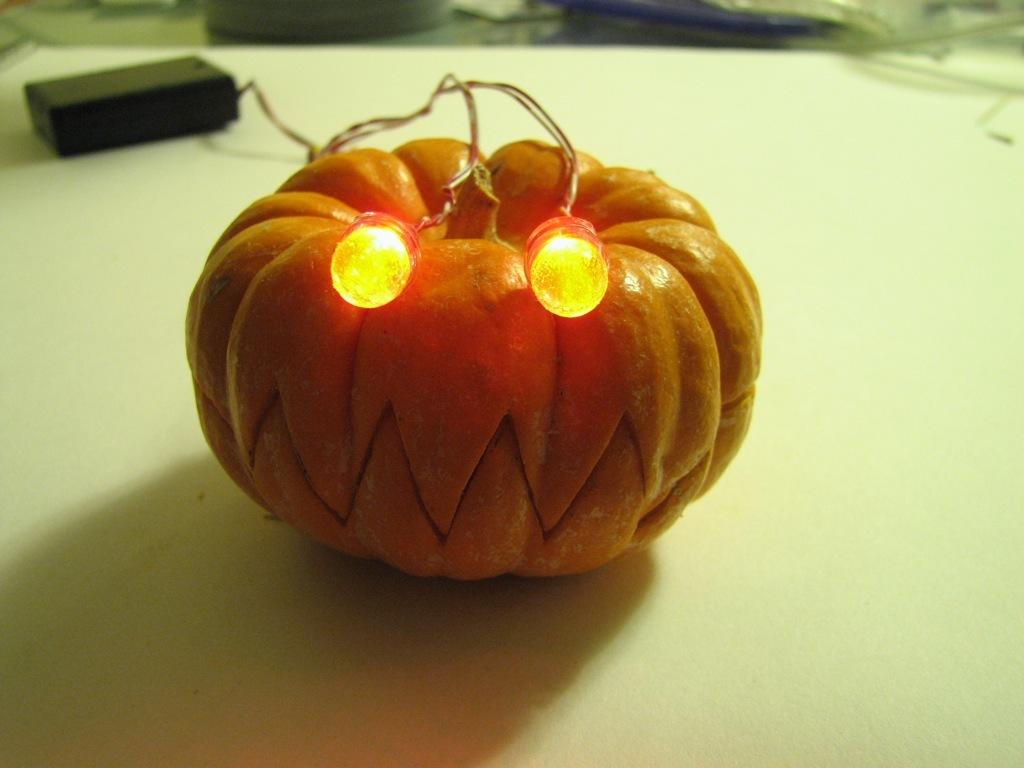What is the color of the pumpkin in the image? The pumpkin in the image is orange. What can be seen illuminated in the image? There are lights visible in the image. What is present alongside the lights? There are wires in the image. What is visible in the background of the image? There is a black color thing in the background of the image. How is the background of the image? The background of the image is slightly blurry. What type of drink is being served by the person's brother in the image? There is no person or brother present in the image, and therefore no drink can be served. 